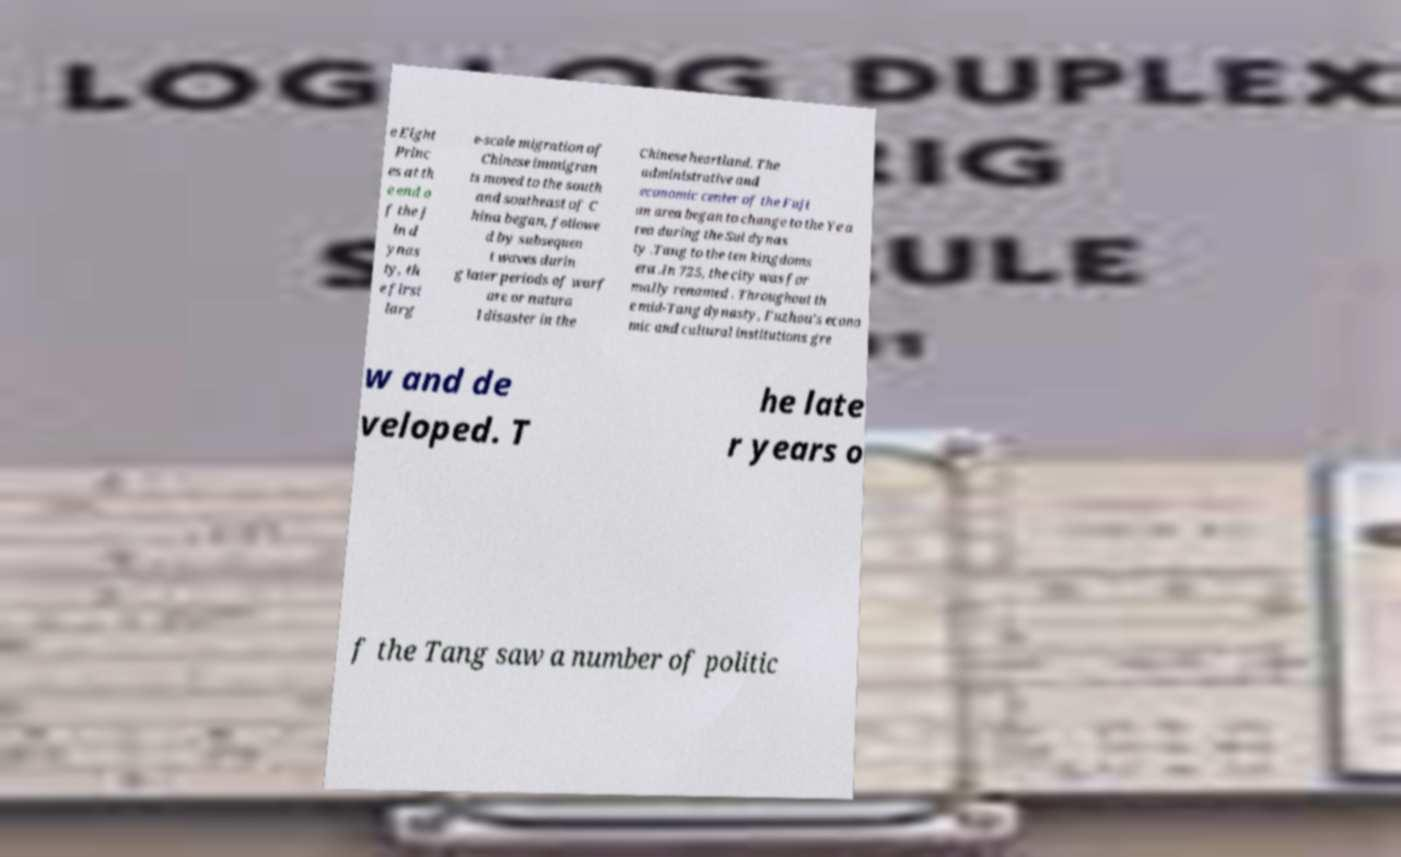I need the written content from this picture converted into text. Can you do that? e Eight Princ es at th e end o f the J in d ynas ty, th e first larg e-scale migration of Chinese immigran ts moved to the south and southeast of C hina began, followe d by subsequen t waves durin g later periods of warf are or natura l disaster in the Chinese heartland. The administrative and economic center of the Fuji an area began to change to the Ye a rea during the Sui dynas ty .Tang to the ten kingdoms era .In 725, the city was for mally renamed . Throughout th e mid-Tang dynasty, Fuzhou's econo mic and cultural institutions gre w and de veloped. T he late r years o f the Tang saw a number of politic 